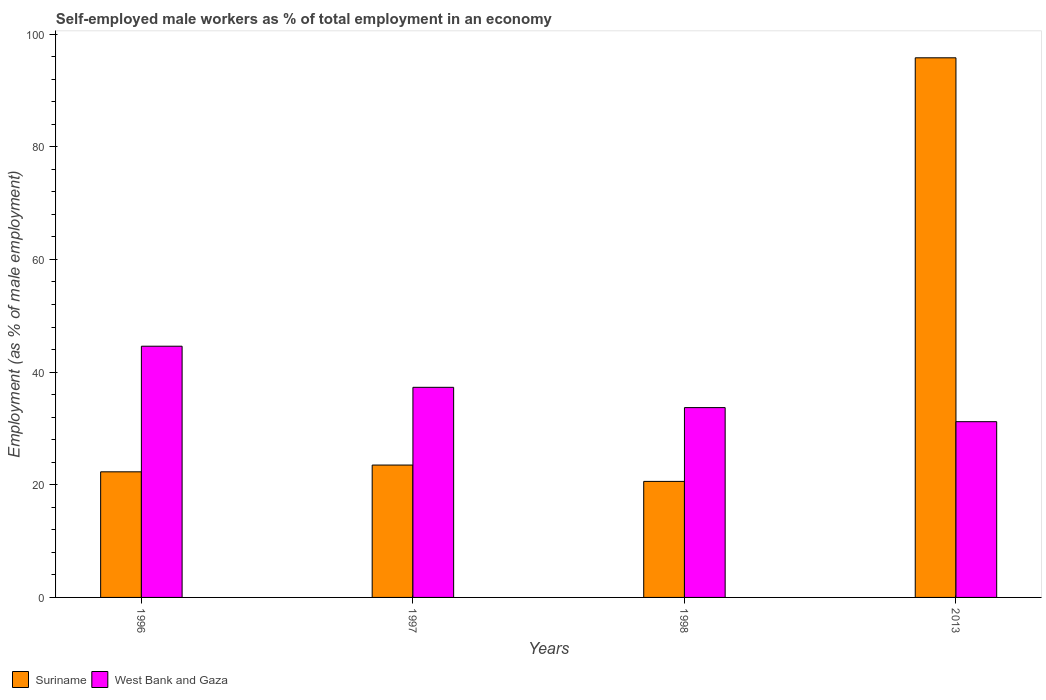How many groups of bars are there?
Provide a succinct answer. 4. Are the number of bars per tick equal to the number of legend labels?
Your response must be concise. Yes. How many bars are there on the 3rd tick from the left?
Provide a short and direct response. 2. How many bars are there on the 1st tick from the right?
Offer a very short reply. 2. What is the label of the 3rd group of bars from the left?
Your response must be concise. 1998. What is the percentage of self-employed male workers in West Bank and Gaza in 1996?
Offer a very short reply. 44.6. Across all years, what is the maximum percentage of self-employed male workers in Suriname?
Offer a terse response. 95.8. Across all years, what is the minimum percentage of self-employed male workers in West Bank and Gaza?
Ensure brevity in your answer.  31.2. What is the total percentage of self-employed male workers in West Bank and Gaza in the graph?
Make the answer very short. 146.8. What is the difference between the percentage of self-employed male workers in Suriname in 1997 and that in 2013?
Keep it short and to the point. -72.3. What is the difference between the percentage of self-employed male workers in Suriname in 1998 and the percentage of self-employed male workers in West Bank and Gaza in 1996?
Offer a very short reply. -24. What is the average percentage of self-employed male workers in Suriname per year?
Make the answer very short. 40.55. In the year 1998, what is the difference between the percentage of self-employed male workers in Suriname and percentage of self-employed male workers in West Bank and Gaza?
Your response must be concise. -13.1. What is the ratio of the percentage of self-employed male workers in Suriname in 1997 to that in 2013?
Offer a terse response. 0.25. Is the percentage of self-employed male workers in West Bank and Gaza in 1996 less than that in 1997?
Offer a terse response. No. Is the difference between the percentage of self-employed male workers in Suriname in 1997 and 2013 greater than the difference between the percentage of self-employed male workers in West Bank and Gaza in 1997 and 2013?
Your answer should be very brief. No. What is the difference between the highest and the second highest percentage of self-employed male workers in Suriname?
Your answer should be very brief. 72.3. What is the difference between the highest and the lowest percentage of self-employed male workers in West Bank and Gaza?
Keep it short and to the point. 13.4. Is the sum of the percentage of self-employed male workers in Suriname in 1998 and 2013 greater than the maximum percentage of self-employed male workers in West Bank and Gaza across all years?
Ensure brevity in your answer.  Yes. What does the 1st bar from the left in 2013 represents?
Provide a short and direct response. Suriname. What does the 1st bar from the right in 1997 represents?
Provide a short and direct response. West Bank and Gaza. How many bars are there?
Give a very brief answer. 8. Are all the bars in the graph horizontal?
Keep it short and to the point. No. How many years are there in the graph?
Your answer should be very brief. 4. What is the difference between two consecutive major ticks on the Y-axis?
Your answer should be compact. 20. Where does the legend appear in the graph?
Ensure brevity in your answer.  Bottom left. What is the title of the graph?
Offer a very short reply. Self-employed male workers as % of total employment in an economy. What is the label or title of the Y-axis?
Give a very brief answer. Employment (as % of male employment). What is the Employment (as % of male employment) in Suriname in 1996?
Make the answer very short. 22.3. What is the Employment (as % of male employment) of West Bank and Gaza in 1996?
Give a very brief answer. 44.6. What is the Employment (as % of male employment) of West Bank and Gaza in 1997?
Offer a terse response. 37.3. What is the Employment (as % of male employment) in Suriname in 1998?
Provide a short and direct response. 20.6. What is the Employment (as % of male employment) of West Bank and Gaza in 1998?
Make the answer very short. 33.7. What is the Employment (as % of male employment) of Suriname in 2013?
Your answer should be compact. 95.8. What is the Employment (as % of male employment) of West Bank and Gaza in 2013?
Your answer should be very brief. 31.2. Across all years, what is the maximum Employment (as % of male employment) of Suriname?
Give a very brief answer. 95.8. Across all years, what is the maximum Employment (as % of male employment) of West Bank and Gaza?
Offer a very short reply. 44.6. Across all years, what is the minimum Employment (as % of male employment) in Suriname?
Keep it short and to the point. 20.6. Across all years, what is the minimum Employment (as % of male employment) of West Bank and Gaza?
Your response must be concise. 31.2. What is the total Employment (as % of male employment) in Suriname in the graph?
Your answer should be compact. 162.2. What is the total Employment (as % of male employment) in West Bank and Gaza in the graph?
Offer a terse response. 146.8. What is the difference between the Employment (as % of male employment) of Suriname in 1996 and that in 1997?
Offer a terse response. -1.2. What is the difference between the Employment (as % of male employment) in Suriname in 1996 and that in 2013?
Your answer should be compact. -73.5. What is the difference between the Employment (as % of male employment) in West Bank and Gaza in 1996 and that in 2013?
Provide a succinct answer. 13.4. What is the difference between the Employment (as % of male employment) of West Bank and Gaza in 1997 and that in 1998?
Keep it short and to the point. 3.6. What is the difference between the Employment (as % of male employment) in Suriname in 1997 and that in 2013?
Provide a short and direct response. -72.3. What is the difference between the Employment (as % of male employment) of West Bank and Gaza in 1997 and that in 2013?
Offer a very short reply. 6.1. What is the difference between the Employment (as % of male employment) of Suriname in 1998 and that in 2013?
Ensure brevity in your answer.  -75.2. What is the difference between the Employment (as % of male employment) in Suriname in 1996 and the Employment (as % of male employment) in West Bank and Gaza in 2013?
Offer a terse response. -8.9. What is the difference between the Employment (as % of male employment) in Suriname in 1997 and the Employment (as % of male employment) in West Bank and Gaza in 1998?
Your answer should be very brief. -10.2. What is the average Employment (as % of male employment) in Suriname per year?
Provide a short and direct response. 40.55. What is the average Employment (as % of male employment) in West Bank and Gaza per year?
Your answer should be very brief. 36.7. In the year 1996, what is the difference between the Employment (as % of male employment) in Suriname and Employment (as % of male employment) in West Bank and Gaza?
Ensure brevity in your answer.  -22.3. In the year 1997, what is the difference between the Employment (as % of male employment) of Suriname and Employment (as % of male employment) of West Bank and Gaza?
Offer a very short reply. -13.8. In the year 2013, what is the difference between the Employment (as % of male employment) in Suriname and Employment (as % of male employment) in West Bank and Gaza?
Make the answer very short. 64.6. What is the ratio of the Employment (as % of male employment) in Suriname in 1996 to that in 1997?
Ensure brevity in your answer.  0.95. What is the ratio of the Employment (as % of male employment) in West Bank and Gaza in 1996 to that in 1997?
Provide a short and direct response. 1.2. What is the ratio of the Employment (as % of male employment) in Suriname in 1996 to that in 1998?
Ensure brevity in your answer.  1.08. What is the ratio of the Employment (as % of male employment) in West Bank and Gaza in 1996 to that in 1998?
Ensure brevity in your answer.  1.32. What is the ratio of the Employment (as % of male employment) of Suriname in 1996 to that in 2013?
Offer a very short reply. 0.23. What is the ratio of the Employment (as % of male employment) in West Bank and Gaza in 1996 to that in 2013?
Make the answer very short. 1.43. What is the ratio of the Employment (as % of male employment) in Suriname in 1997 to that in 1998?
Your answer should be very brief. 1.14. What is the ratio of the Employment (as % of male employment) of West Bank and Gaza in 1997 to that in 1998?
Your answer should be compact. 1.11. What is the ratio of the Employment (as % of male employment) in Suriname in 1997 to that in 2013?
Offer a terse response. 0.25. What is the ratio of the Employment (as % of male employment) of West Bank and Gaza in 1997 to that in 2013?
Give a very brief answer. 1.2. What is the ratio of the Employment (as % of male employment) in Suriname in 1998 to that in 2013?
Give a very brief answer. 0.21. What is the ratio of the Employment (as % of male employment) in West Bank and Gaza in 1998 to that in 2013?
Make the answer very short. 1.08. What is the difference between the highest and the second highest Employment (as % of male employment) in Suriname?
Provide a succinct answer. 72.3. What is the difference between the highest and the lowest Employment (as % of male employment) of Suriname?
Your answer should be compact. 75.2. 